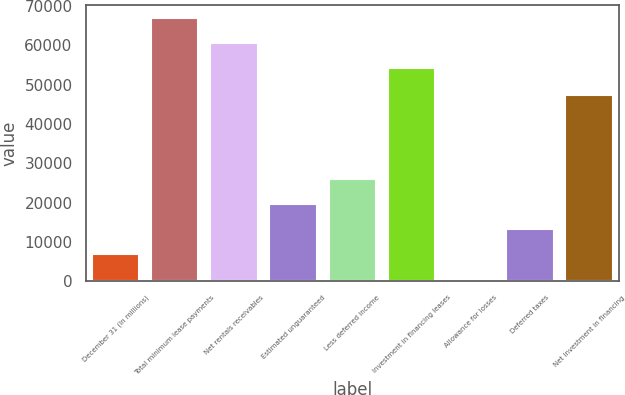<chart> <loc_0><loc_0><loc_500><loc_500><bar_chart><fcel>December 31 (In millions)<fcel>Total minimum lease payments<fcel>Net rentals receivables<fcel>Estimated unguaranteed<fcel>Less deferred income<fcel>Investment in financing leases<fcel>Allowance for losses<fcel>Deferred taxes<fcel>Net investment in financing<nl><fcel>6988.3<fcel>67000.6<fcel>60666.3<fcel>19656.9<fcel>25991.2<fcel>54332<fcel>654<fcel>13322.6<fcel>47468<nl></chart> 